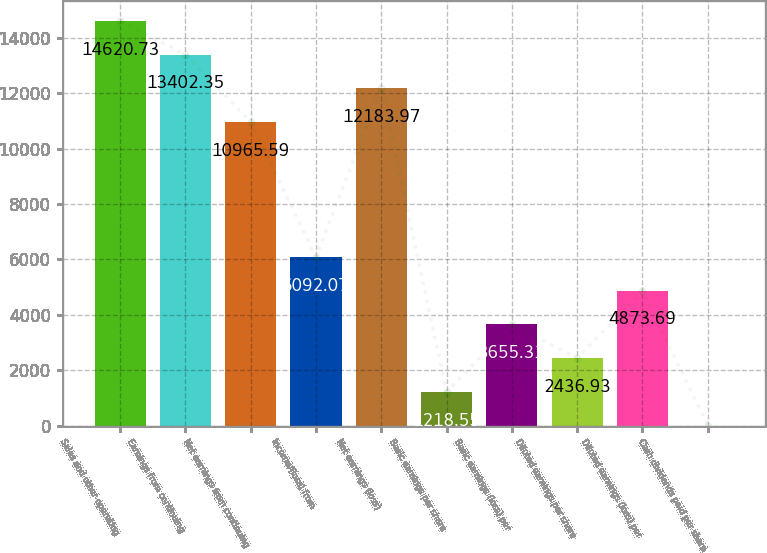Convert chart to OTSL. <chart><loc_0><loc_0><loc_500><loc_500><bar_chart><fcel>Sales and other operating<fcel>Earnings from continuing<fcel>Net earnings from continuing<fcel>Income/(loss) from<fcel>Net earnings (loss)<fcel>Basic earnings per share<fcel>Basic earnings (loss) per<fcel>Diluted earnings per share<fcel>Diluted earnings (loss) per<fcel>Cash dividends paid per share<nl><fcel>14620.7<fcel>13402.4<fcel>10965.6<fcel>6092.07<fcel>12184<fcel>1218.55<fcel>3655.31<fcel>2436.93<fcel>4873.69<fcel>0.17<nl></chart> 